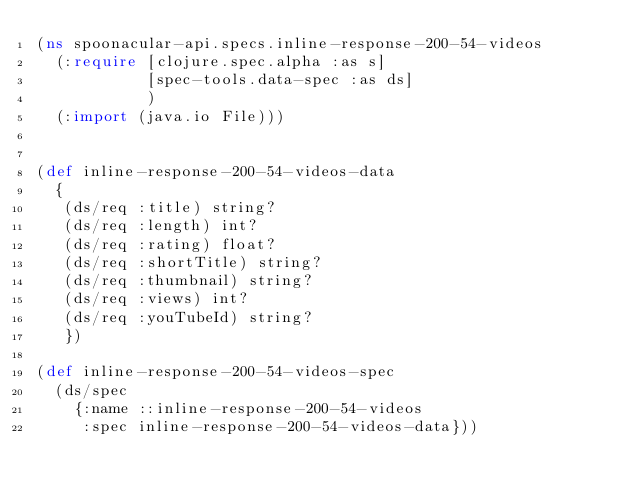<code> <loc_0><loc_0><loc_500><loc_500><_Clojure_>(ns spoonacular-api.specs.inline-response-200-54-videos
  (:require [clojure.spec.alpha :as s]
            [spec-tools.data-spec :as ds]
            )
  (:import (java.io File)))


(def inline-response-200-54-videos-data
  {
   (ds/req :title) string?
   (ds/req :length) int?
   (ds/req :rating) float?
   (ds/req :shortTitle) string?
   (ds/req :thumbnail) string?
   (ds/req :views) int?
   (ds/req :youTubeId) string?
   })

(def inline-response-200-54-videos-spec
  (ds/spec
    {:name ::inline-response-200-54-videos
     :spec inline-response-200-54-videos-data}))
</code> 